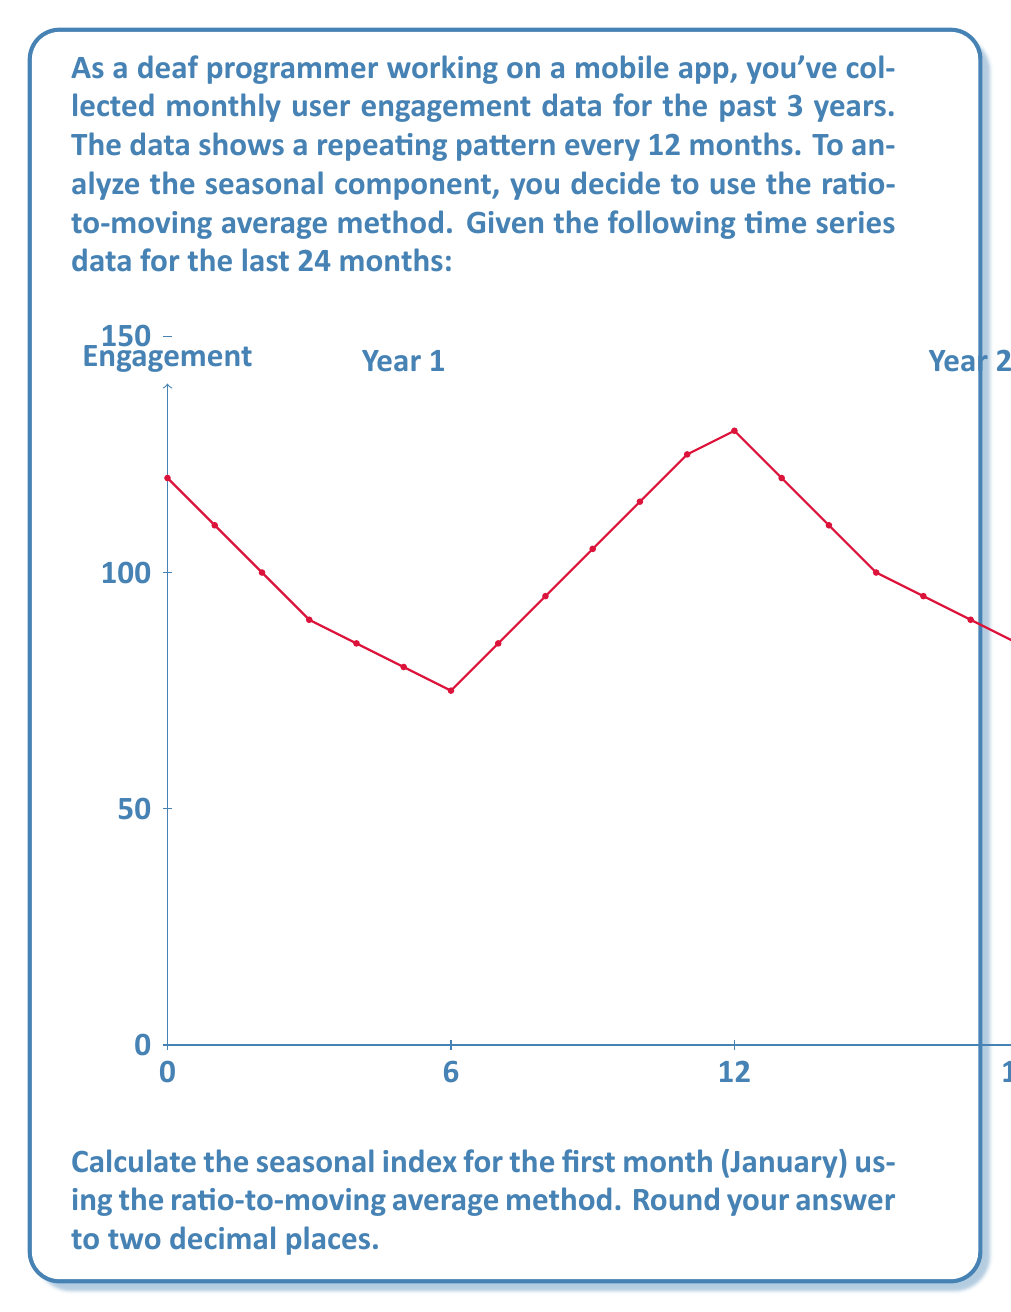Teach me how to tackle this problem. To calculate the seasonal index using the ratio-to-moving average method, we'll follow these steps:

1. Calculate the 12-month centered moving average:
   For the first complete year (months 6-17):
   $$ MA = \frac{80 + 75 + 85 + 95 + 105 + 115 + 125 + 130 + 120 + 110 + 100 + 95}{12} = 103.75 $$

2. Calculate the ratio of the actual value to the moving average:
   For January of Year 2 (month 13):
   $$ Ratio = \frac{Actual}{MA} = \frac{130}{103.75} = 1.2530 $$

3. Repeat this process for all Januaries in the dataset. In this case, we only have two Januaries:
   Year 1: $\frac{120}{103.75} = 1.1565$
   Year 2: $\frac{130}{103.75} = 1.2530$

4. Calculate the average of these ratios:
   $$ Seasonal\,Index = \frac{1.1565 + 1.2530}{2} = 1.20475 $$

5. Round to two decimal places:
   $$ Seasonal\,Index = 1.20 $$

This means that, on average, January's engagement is 20% higher than the overall trend.
Answer: 1.20 